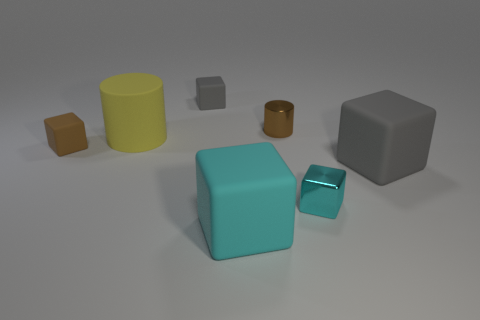How many cyan cubes must be subtracted to get 1 cyan cubes? 1 Subtract all gray cylinders. How many gray cubes are left? 2 Subtract all rubber blocks. How many blocks are left? 1 Subtract 3 blocks. How many blocks are left? 2 Subtract all cyan blocks. How many blocks are left? 3 Add 1 big yellow rubber cylinders. How many objects exist? 8 Subtract all yellow blocks. Subtract all purple cylinders. How many blocks are left? 5 Subtract all cylinders. How many objects are left? 5 Add 4 small brown rubber things. How many small brown rubber things are left? 5 Add 5 small brown metal objects. How many small brown metal objects exist? 6 